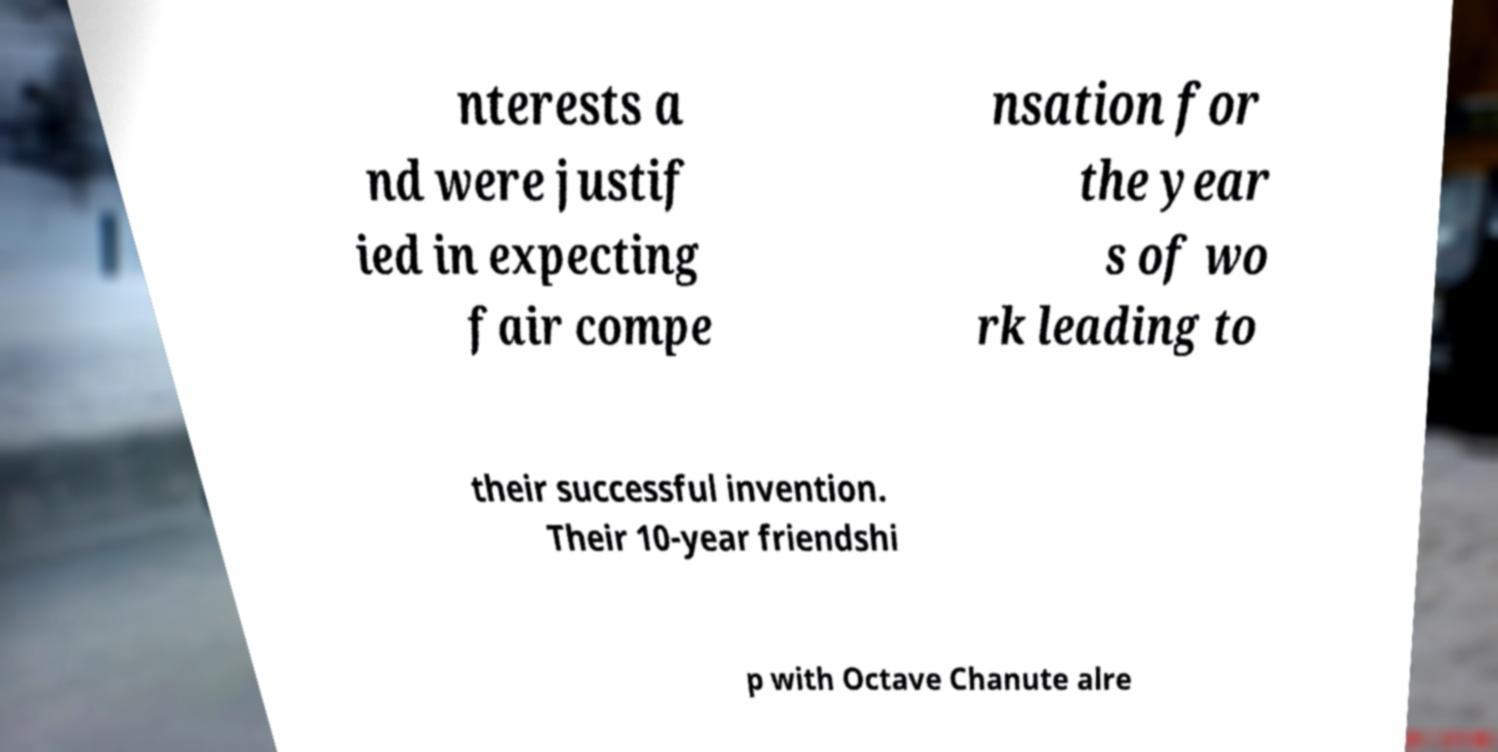Can you accurately transcribe the text from the provided image for me? nterests a nd were justif ied in expecting fair compe nsation for the year s of wo rk leading to their successful invention. Their 10-year friendshi p with Octave Chanute alre 